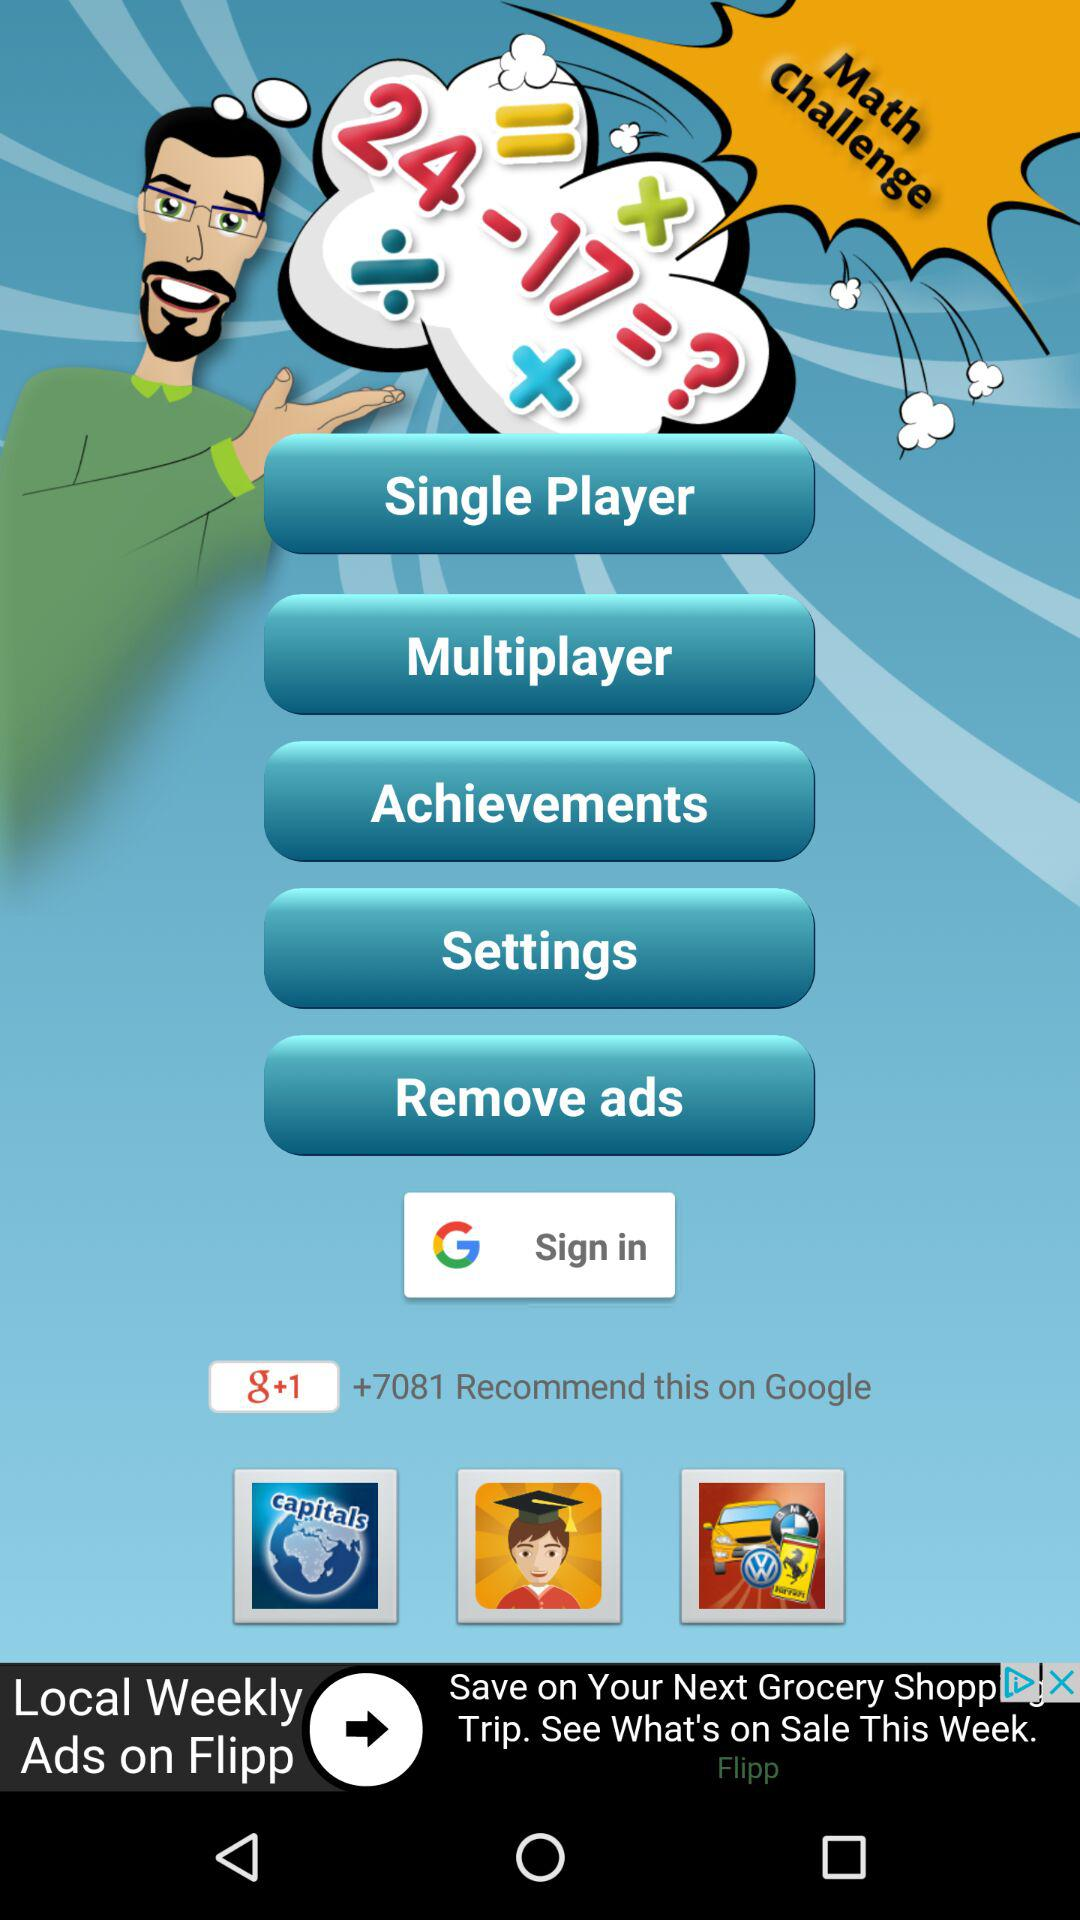Through what application can we sign in? You can sign in through Google. 